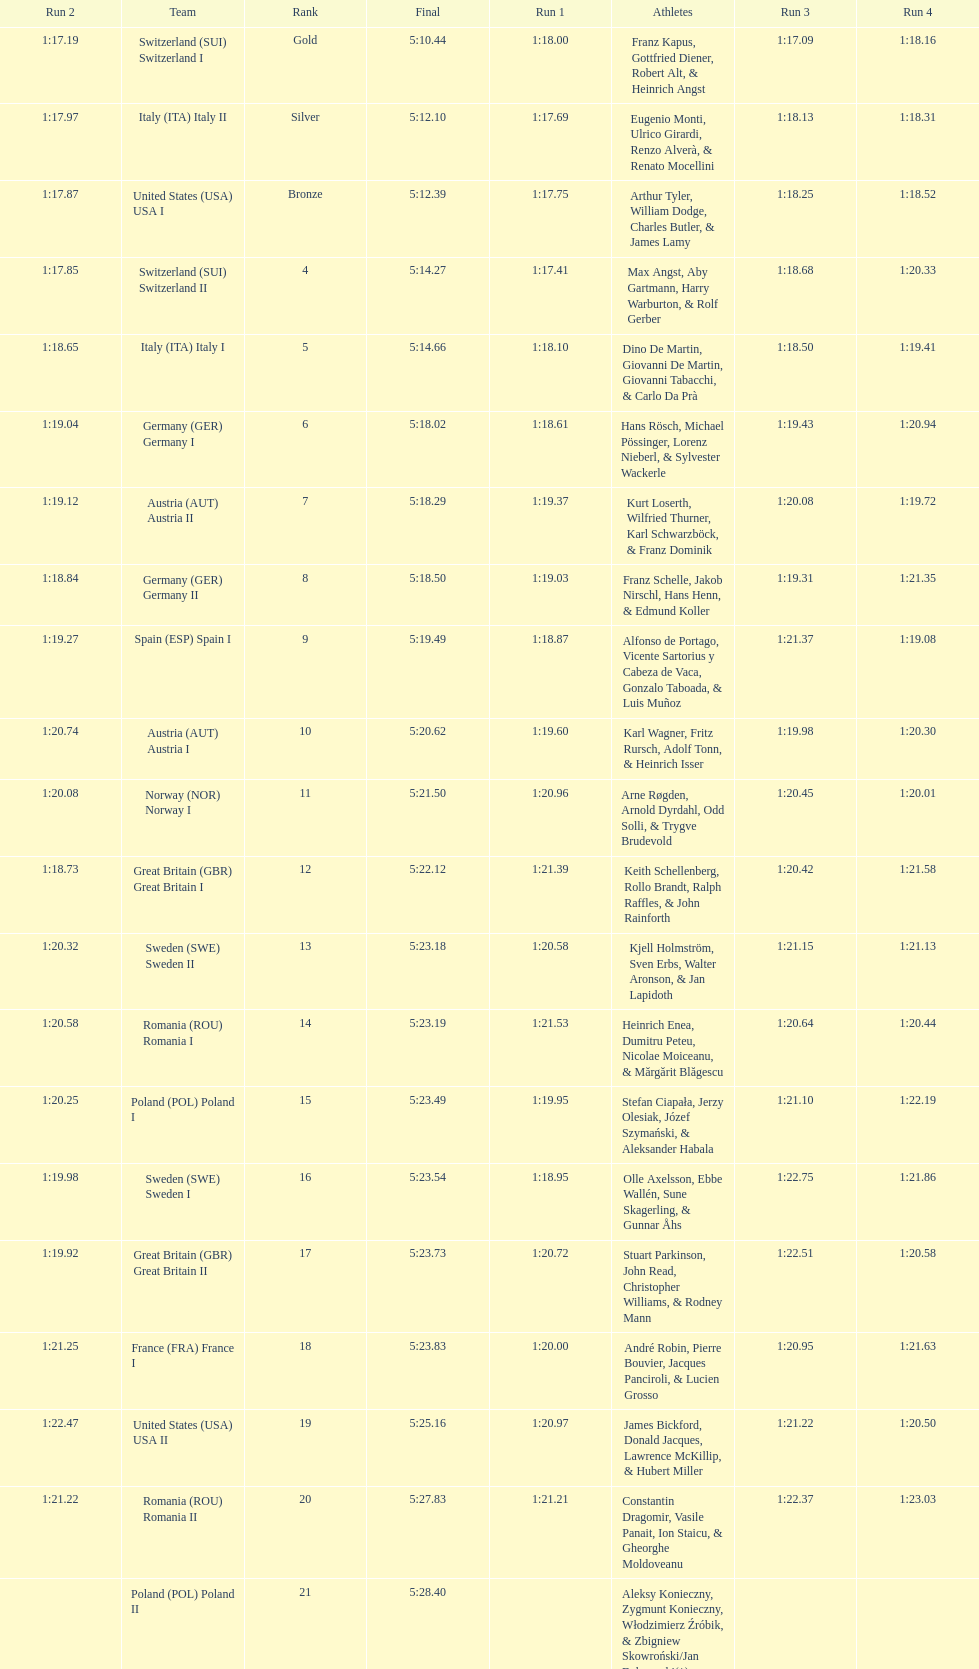What team comes after italy (ita) italy i? Germany I. Give me the full table as a dictionary. {'header': ['Run 2', 'Team', 'Rank', 'Final', 'Run 1', 'Athletes', 'Run 3', 'Run 4'], 'rows': [['1:17.19', 'Switzerland\xa0(SUI) Switzerland I', 'Gold', '5:10.44', '1:18.00', 'Franz Kapus, Gottfried Diener, Robert Alt, & Heinrich Angst', '1:17.09', '1:18.16'], ['1:17.97', 'Italy\xa0(ITA) Italy II', 'Silver', '5:12.10', '1:17.69', 'Eugenio Monti, Ulrico Girardi, Renzo Alverà, & Renato Mocellini', '1:18.13', '1:18.31'], ['1:17.87', 'United States\xa0(USA) USA I', 'Bronze', '5:12.39', '1:17.75', 'Arthur Tyler, William Dodge, Charles Butler, & James Lamy', '1:18.25', '1:18.52'], ['1:17.85', 'Switzerland\xa0(SUI) Switzerland II', '4', '5:14.27', '1:17.41', 'Max Angst, Aby Gartmann, Harry Warburton, & Rolf Gerber', '1:18.68', '1:20.33'], ['1:18.65', 'Italy\xa0(ITA) Italy I', '5', '5:14.66', '1:18.10', 'Dino De Martin, Giovanni De Martin, Giovanni Tabacchi, & Carlo Da Prà', '1:18.50', '1:19.41'], ['1:19.04', 'Germany\xa0(GER) Germany I', '6', '5:18.02', '1:18.61', 'Hans Rösch, Michael Pössinger, Lorenz Nieberl, & Sylvester Wackerle', '1:19.43', '1:20.94'], ['1:19.12', 'Austria\xa0(AUT) Austria II', '7', '5:18.29', '1:19.37', 'Kurt Loserth, Wilfried Thurner, Karl Schwarzböck, & Franz Dominik', '1:20.08', '1:19.72'], ['1:18.84', 'Germany\xa0(GER) Germany II', '8', '5:18.50', '1:19.03', 'Franz Schelle, Jakob Nirschl, Hans Henn, & Edmund Koller', '1:19.31', '1:21.35'], ['1:19.27', 'Spain\xa0(ESP) Spain I', '9', '5:19.49', '1:18.87', 'Alfonso de Portago, Vicente Sartorius y Cabeza de Vaca, Gonzalo Taboada, & Luis Muñoz', '1:21.37', '1:19.08'], ['1:20.74', 'Austria\xa0(AUT) Austria I', '10', '5:20.62', '1:19.60', 'Karl Wagner, Fritz Rursch, Adolf Tonn, & Heinrich Isser', '1:19.98', '1:20.30'], ['1:20.08', 'Norway\xa0(NOR) Norway I', '11', '5:21.50', '1:20.96', 'Arne Røgden, Arnold Dyrdahl, Odd Solli, & Trygve Brudevold', '1:20.45', '1:20.01'], ['1:18.73', 'Great Britain\xa0(GBR) Great Britain I', '12', '5:22.12', '1:21.39', 'Keith Schellenberg, Rollo Brandt, Ralph Raffles, & John Rainforth', '1:20.42', '1:21.58'], ['1:20.32', 'Sweden\xa0(SWE) Sweden II', '13', '5:23.18', '1:20.58', 'Kjell Holmström, Sven Erbs, Walter Aronson, & Jan Lapidoth', '1:21.15', '1:21.13'], ['1:20.58', 'Romania\xa0(ROU) Romania I', '14', '5:23.19', '1:21.53', 'Heinrich Enea, Dumitru Peteu, Nicolae Moiceanu, & Mărgărit Blăgescu', '1:20.64', '1:20.44'], ['1:20.25', 'Poland\xa0(POL) Poland I', '15', '5:23.49', '1:19.95', 'Stefan Ciapała, Jerzy Olesiak, Józef Szymański, & Aleksander Habala', '1:21.10', '1:22.19'], ['1:19.98', 'Sweden\xa0(SWE) Sweden I', '16', '5:23.54', '1:18.95', 'Olle Axelsson, Ebbe Wallén, Sune Skagerling, & Gunnar Åhs', '1:22.75', '1:21.86'], ['1:19.92', 'Great Britain\xa0(GBR) Great Britain II', '17', '5:23.73', '1:20.72', 'Stuart Parkinson, John Read, Christopher Williams, & Rodney Mann', '1:22.51', '1:20.58'], ['1:21.25', 'France\xa0(FRA) France I', '18', '5:23.83', '1:20.00', 'André Robin, Pierre Bouvier, Jacques Panciroli, & Lucien Grosso', '1:20.95', '1:21.63'], ['1:22.47', 'United States\xa0(USA) USA II', '19', '5:25.16', '1:20.97', 'James Bickford, Donald Jacques, Lawrence McKillip, & Hubert Miller', '1:21.22', '1:20.50'], ['1:21.22', 'Romania\xa0(ROU) Romania II', '20', '5:27.83', '1:21.21', 'Constantin Dragomir, Vasile Panait, Ion Staicu, & Gheorghe Moldoveanu', '1:22.37', '1:23.03'], ['', 'Poland\xa0(POL) Poland II', '21', '5:28.40', '', 'Aleksy Konieczny, Zygmunt Konieczny, Włodzimierz Źróbik, & Zbigniew Skowroński/Jan Dąbrowski(*)', '', '']]} 